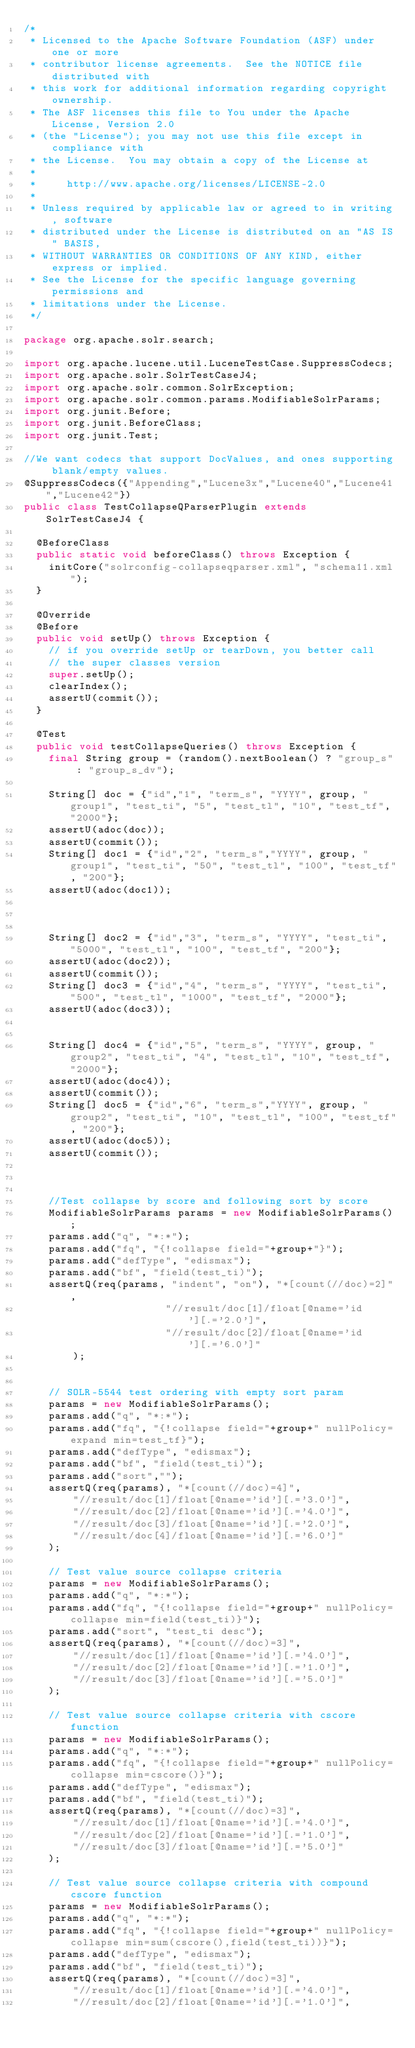Convert code to text. <code><loc_0><loc_0><loc_500><loc_500><_Java_>/*
 * Licensed to the Apache Software Foundation (ASF) under one or more
 * contributor license agreements.  See the NOTICE file distributed with
 * this work for additional information regarding copyright ownership.
 * The ASF licenses this file to You under the Apache License, Version 2.0
 * (the "License"); you may not use this file except in compliance with
 * the License.  You may obtain a copy of the License at
 *
 *     http://www.apache.org/licenses/LICENSE-2.0
 *
 * Unless required by applicable law or agreed to in writing, software
 * distributed under the License is distributed on an "AS IS" BASIS,
 * WITHOUT WARRANTIES OR CONDITIONS OF ANY KIND, either express or implied.
 * See the License for the specific language governing permissions and
 * limitations under the License.
 */

package org.apache.solr.search;

import org.apache.lucene.util.LuceneTestCase.SuppressCodecs;
import org.apache.solr.SolrTestCaseJ4;
import org.apache.solr.common.SolrException;
import org.apache.solr.common.params.ModifiableSolrParams;
import org.junit.Before;
import org.junit.BeforeClass;
import org.junit.Test;

//We want codecs that support DocValues, and ones supporting blank/empty values.
@SuppressCodecs({"Appending","Lucene3x","Lucene40","Lucene41","Lucene42"})
public class TestCollapseQParserPlugin extends SolrTestCaseJ4 {

  @BeforeClass
  public static void beforeClass() throws Exception {
    initCore("solrconfig-collapseqparser.xml", "schema11.xml");
  }

  @Override
  @Before
  public void setUp() throws Exception {
    // if you override setUp or tearDown, you better call
    // the super classes version
    super.setUp();
    clearIndex();
    assertU(commit());
  }

  @Test
  public void testCollapseQueries() throws Exception {
    final String group = (random().nextBoolean() ? "group_s" : "group_s_dv");
    
    String[] doc = {"id","1", "term_s", "YYYY", group, "group1", "test_ti", "5", "test_tl", "10", "test_tf", "2000"};
    assertU(adoc(doc));
    assertU(commit());
    String[] doc1 = {"id","2", "term_s","YYYY", group, "group1", "test_ti", "50", "test_tl", "100", "test_tf", "200"};
    assertU(adoc(doc1));



    String[] doc2 = {"id","3", "term_s", "YYYY", "test_ti", "5000", "test_tl", "100", "test_tf", "200"};
    assertU(adoc(doc2));
    assertU(commit());
    String[] doc3 = {"id","4", "term_s", "YYYY", "test_ti", "500", "test_tl", "1000", "test_tf", "2000"};
    assertU(adoc(doc3));


    String[] doc4 = {"id","5", "term_s", "YYYY", group, "group2", "test_ti", "4", "test_tl", "10", "test_tf", "2000"};
    assertU(adoc(doc4));
    assertU(commit());
    String[] doc5 = {"id","6", "term_s","YYYY", group, "group2", "test_ti", "10", "test_tl", "100", "test_tf", "200"};
    assertU(adoc(doc5));
    assertU(commit());



    //Test collapse by score and following sort by score
    ModifiableSolrParams params = new ModifiableSolrParams();
    params.add("q", "*:*");
    params.add("fq", "{!collapse field="+group+"}");
    params.add("defType", "edismax");
    params.add("bf", "field(test_ti)");
    assertQ(req(params, "indent", "on"), "*[count(//doc)=2]",
                       "//result/doc[1]/float[@name='id'][.='2.0']",
                       "//result/doc[2]/float[@name='id'][.='6.0']"
        );


    // SOLR-5544 test ordering with empty sort param
    params = new ModifiableSolrParams();
    params.add("q", "*:*");
    params.add("fq", "{!collapse field="+group+" nullPolicy=expand min=test_tf}");
    params.add("defType", "edismax");
    params.add("bf", "field(test_ti)");
    params.add("sort","");
    assertQ(req(params), "*[count(//doc)=4]",
        "//result/doc[1]/float[@name='id'][.='3.0']",
        "//result/doc[2]/float[@name='id'][.='4.0']",
        "//result/doc[3]/float[@name='id'][.='2.0']",
        "//result/doc[4]/float[@name='id'][.='6.0']"
    );

    // Test value source collapse criteria
    params = new ModifiableSolrParams();
    params.add("q", "*:*");
    params.add("fq", "{!collapse field="+group+" nullPolicy=collapse min=field(test_ti)}");
    params.add("sort", "test_ti desc");
    assertQ(req(params), "*[count(//doc)=3]",
        "//result/doc[1]/float[@name='id'][.='4.0']",
        "//result/doc[2]/float[@name='id'][.='1.0']",
        "//result/doc[3]/float[@name='id'][.='5.0']"
    );

    // Test value source collapse criteria with cscore function
    params = new ModifiableSolrParams();
    params.add("q", "*:*");
    params.add("fq", "{!collapse field="+group+" nullPolicy=collapse min=cscore()}");
    params.add("defType", "edismax");
    params.add("bf", "field(test_ti)");
    assertQ(req(params), "*[count(//doc)=3]",
        "//result/doc[1]/float[@name='id'][.='4.0']",
        "//result/doc[2]/float[@name='id'][.='1.0']",
        "//result/doc[3]/float[@name='id'][.='5.0']"
    );

    // Test value source collapse criteria with compound cscore function
    params = new ModifiableSolrParams();
    params.add("q", "*:*");
    params.add("fq", "{!collapse field="+group+" nullPolicy=collapse min=sum(cscore(),field(test_ti))}");
    params.add("defType", "edismax");
    params.add("bf", "field(test_ti)");
    assertQ(req(params), "*[count(//doc)=3]",
        "//result/doc[1]/float[@name='id'][.='4.0']",
        "//result/doc[2]/float[@name='id'][.='1.0']",</code> 